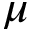<formula> <loc_0><loc_0><loc_500><loc_500>\mu</formula> 